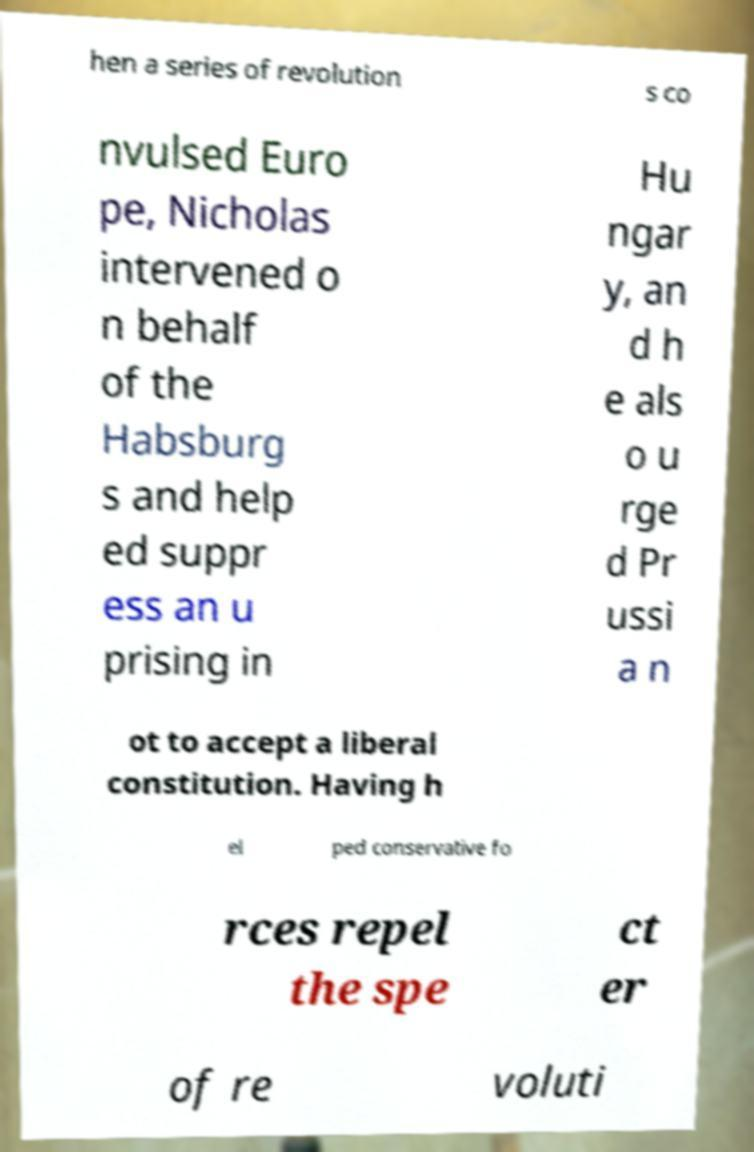For documentation purposes, I need the text within this image transcribed. Could you provide that? hen a series of revolution s co nvulsed Euro pe, Nicholas intervened o n behalf of the Habsburg s and help ed suppr ess an u prising in Hu ngar y, an d h e als o u rge d Pr ussi a n ot to accept a liberal constitution. Having h el ped conservative fo rces repel the spe ct er of re voluti 